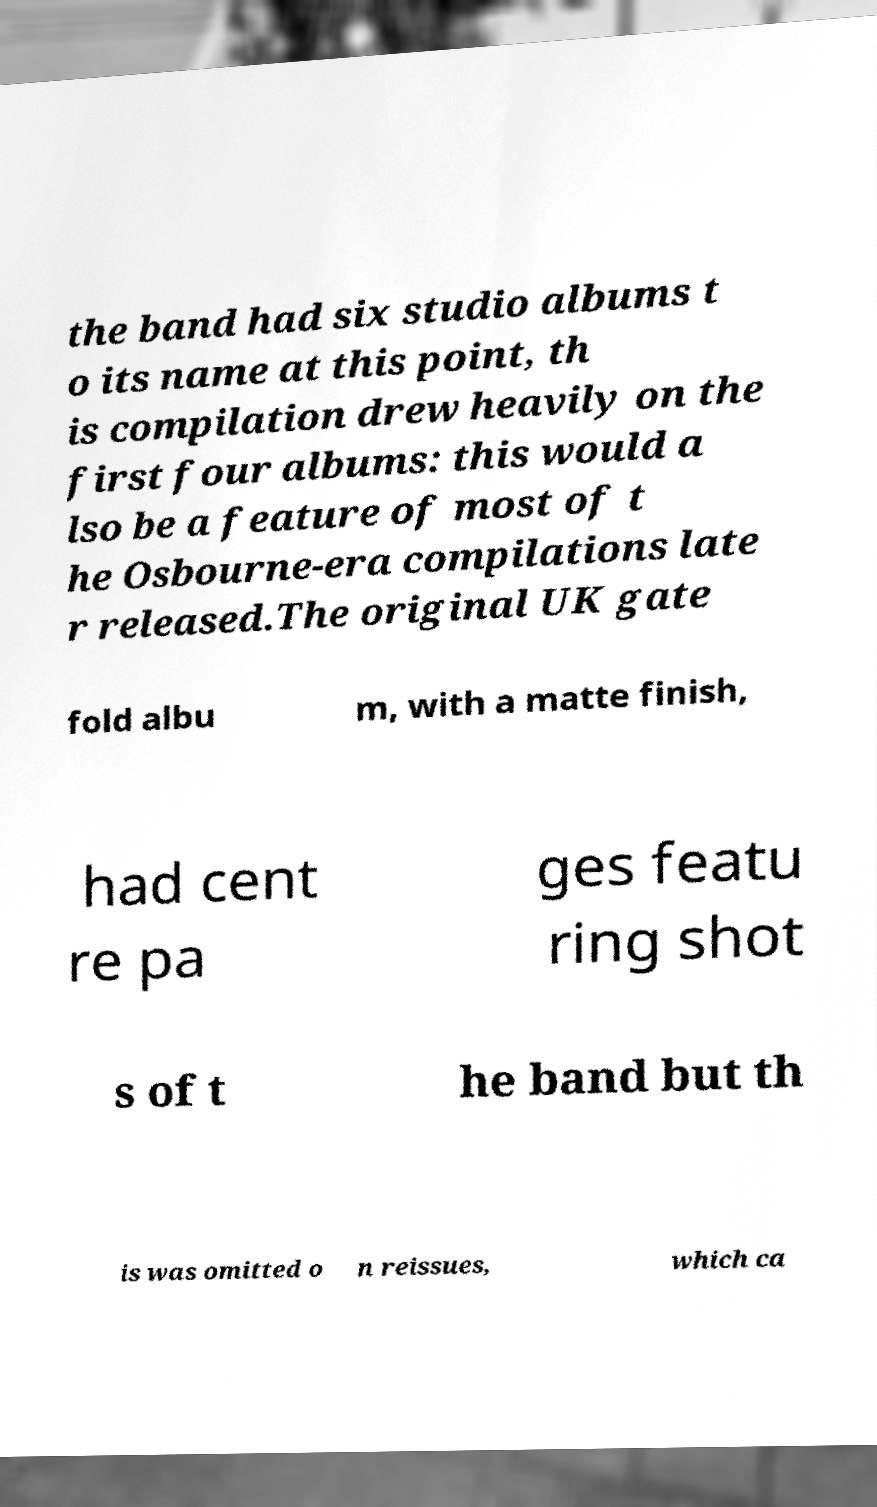What messages or text are displayed in this image? I need them in a readable, typed format. the band had six studio albums t o its name at this point, th is compilation drew heavily on the first four albums: this would a lso be a feature of most of t he Osbourne-era compilations late r released.The original UK gate fold albu m, with a matte finish, had cent re pa ges featu ring shot s of t he band but th is was omitted o n reissues, which ca 